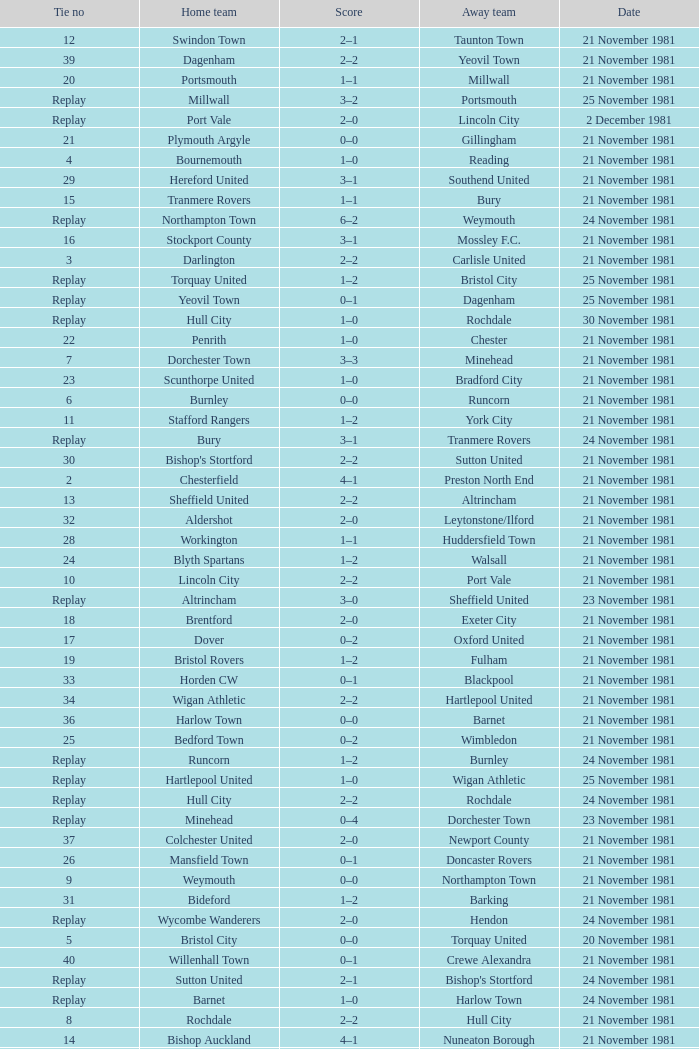What is enfield's tie number? 1.0. 